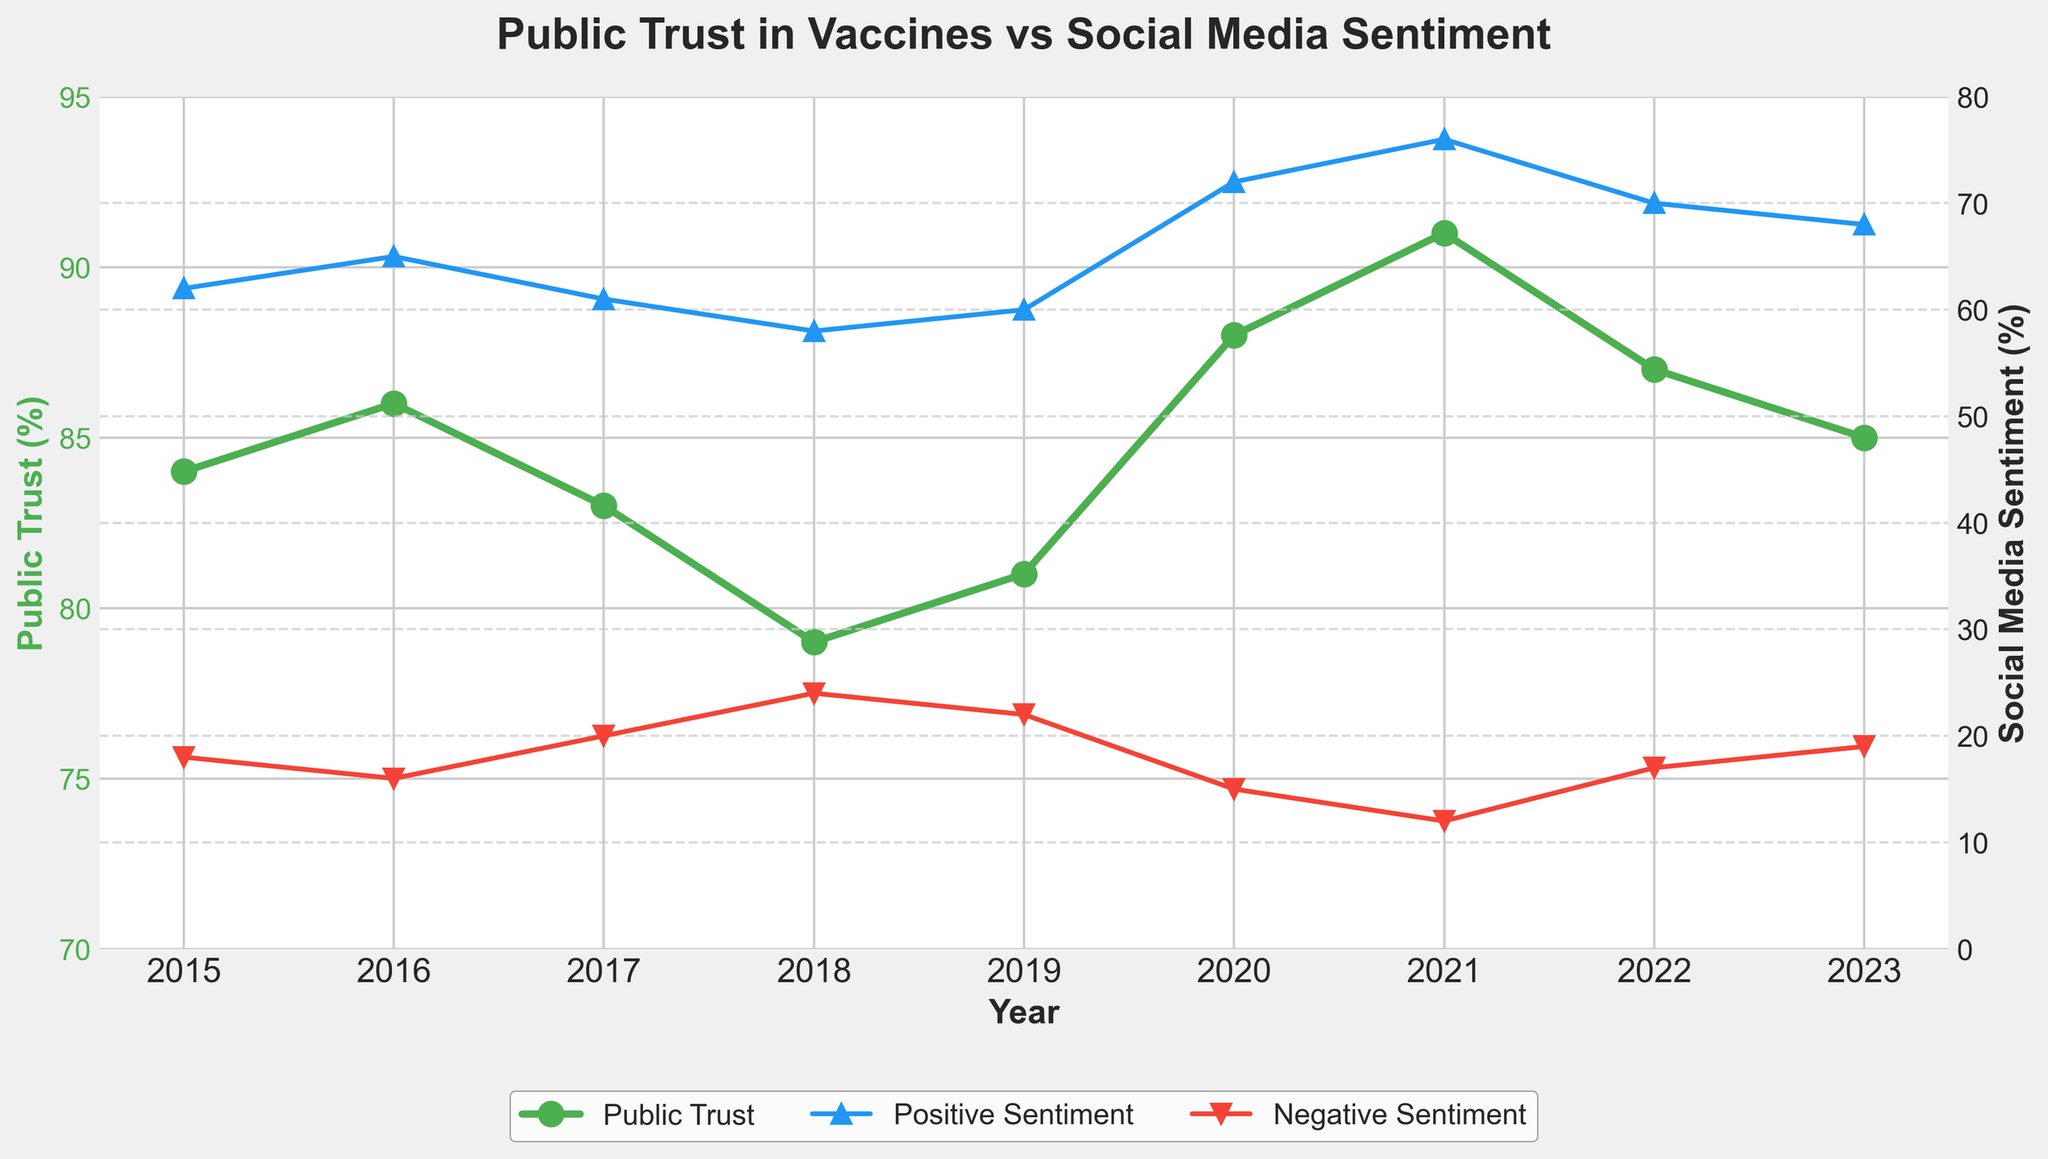What is the general trend of public trust in vaccines from 2015 to 2023? The line representing public trust in vaccines shows an initial increase from 2015 to 2016, followed by a slight decrease until 2018, then a significant increase until 2021, and a slight decline afterward.
Answer: Up, down, up, down How does the trend in positive social media sentiment compare to the trend in public trust in vaccines? Both public trust in vaccines and positive social media sentiment generally follow a similar trend: increasing from 2015 to 2016, then decreasing towards 2018, followed by a significant increase until around 2020-2021, and a slight decline after that.
Answer: Similar trends What year did public trust in vaccines peak? Public trust in vaccines peaked in 2021 as indicated by the highest value on the public trust line.
Answer: 2021 During which years did negative social media sentiment increase? Negative social media sentiment increased between 2016 and 2017, and again from 2017 to 2018 according to the upward trends in the negative sentiment line between these years.
Answer: 2016-2018 Calculate the average public trust in vaccines from 2015 to 2023. Summing up the values from 2015 to 2023 (84 + 86 + 83 + 79 + 81 + 88 + 91 + 87 + 85) equals 764. Dividing by the number of years (9) gives an average of 764/9.
Answer: 84.89% Which year had the lowest positive social media sentiment? The lowest positive social media sentiment occurred in 2018 as indicated by the lowest point on the positive sentiment line.
Answer: 2018 Compare the values of public trust in vaccines and positive social media sentiment for the year 2020. In 2020, public trust in vaccines is 88% while positive social media sentiment is 72%.
Answer: Trust: 88%, Sentiment: 72% What is the difference between public trust in vaccines and negative social media sentiment in 2019? In 2019, public trust in vaccines was 81% and negative social media sentiment was 22%. The difference is 81% - 22%.
Answer: 59% How did negative social media sentiment change from 2021 to 2022? Negative social media sentiment increased from 12% in 2021 to 17% in 2022, indicated by the rise in the negative sentiment line.
Answer: Increased What correlation can be inferred between positive social media sentiment and public trust in vaccines? Generally, both positive social media sentiment and public trust in vaccines tend to increase and decrease together, suggesting a positive correlation.
Answer: Positive correlation 